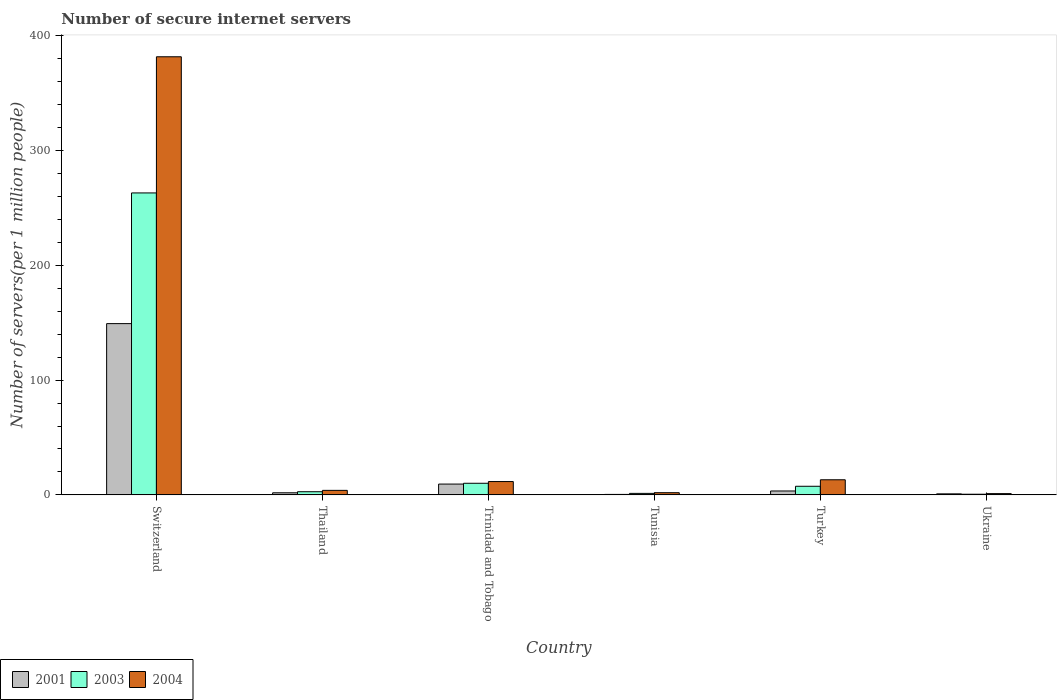How many different coloured bars are there?
Offer a terse response. 3. Are the number of bars on each tick of the X-axis equal?
Give a very brief answer. Yes. How many bars are there on the 1st tick from the left?
Offer a terse response. 3. How many bars are there on the 3rd tick from the right?
Ensure brevity in your answer.  3. What is the number of secure internet servers in 2001 in Turkey?
Keep it short and to the point. 3.41. Across all countries, what is the maximum number of secure internet servers in 2001?
Make the answer very short. 149.24. Across all countries, what is the minimum number of secure internet servers in 2004?
Make the answer very short. 1.12. In which country was the number of secure internet servers in 2003 maximum?
Provide a short and direct response. Switzerland. In which country was the number of secure internet servers in 2001 minimum?
Make the answer very short. Tunisia. What is the total number of secure internet servers in 2001 in the graph?
Provide a short and direct response. 165.23. What is the difference between the number of secure internet servers in 2003 in Trinidad and Tobago and that in Turkey?
Offer a very short reply. 2.62. What is the difference between the number of secure internet servers in 2003 in Trinidad and Tobago and the number of secure internet servers in 2001 in Turkey?
Ensure brevity in your answer.  6.71. What is the average number of secure internet servers in 2004 per country?
Offer a very short reply. 68.92. What is the difference between the number of secure internet servers of/in 2004 and number of secure internet servers of/in 2003 in Switzerland?
Provide a short and direct response. 118.64. In how many countries, is the number of secure internet servers in 2001 greater than 180?
Your answer should be compact. 0. What is the ratio of the number of secure internet servers in 2004 in Switzerland to that in Trinidad and Tobago?
Make the answer very short. 32.84. Is the number of secure internet servers in 2001 in Trinidad and Tobago less than that in Ukraine?
Offer a very short reply. No. What is the difference between the highest and the second highest number of secure internet servers in 2003?
Your answer should be compact. 2.62. What is the difference between the highest and the lowest number of secure internet servers in 2001?
Keep it short and to the point. 148.83. Is the sum of the number of secure internet servers in 2004 in Tunisia and Turkey greater than the maximum number of secure internet servers in 2003 across all countries?
Provide a short and direct response. No. What does the 1st bar from the left in Switzerland represents?
Ensure brevity in your answer.  2001. Is it the case that in every country, the sum of the number of secure internet servers in 2001 and number of secure internet servers in 2004 is greater than the number of secure internet servers in 2003?
Keep it short and to the point. Yes. How many bars are there?
Your answer should be compact. 18. Are all the bars in the graph horizontal?
Ensure brevity in your answer.  No. How many countries are there in the graph?
Provide a short and direct response. 6. What is the difference between two consecutive major ticks on the Y-axis?
Provide a succinct answer. 100. Are the values on the major ticks of Y-axis written in scientific E-notation?
Your answer should be very brief. No. How many legend labels are there?
Provide a short and direct response. 3. What is the title of the graph?
Make the answer very short. Number of secure internet servers. What is the label or title of the Y-axis?
Provide a short and direct response. Number of servers(per 1 million people). What is the Number of servers(per 1 million people) of 2001 in Switzerland?
Make the answer very short. 149.24. What is the Number of servers(per 1 million people) in 2003 in Switzerland?
Provide a short and direct response. 263.11. What is the Number of servers(per 1 million people) in 2004 in Switzerland?
Your answer should be compact. 381.75. What is the Number of servers(per 1 million people) of 2001 in Thailand?
Provide a short and direct response. 1.83. What is the Number of servers(per 1 million people) in 2003 in Thailand?
Provide a short and direct response. 2.76. What is the Number of servers(per 1 million people) of 2004 in Thailand?
Give a very brief answer. 3.94. What is the Number of servers(per 1 million people) in 2001 in Trinidad and Tobago?
Provide a succinct answer. 9.43. What is the Number of servers(per 1 million people) in 2003 in Trinidad and Tobago?
Provide a succinct answer. 10.12. What is the Number of servers(per 1 million people) of 2004 in Trinidad and Tobago?
Make the answer very short. 11.62. What is the Number of servers(per 1 million people) in 2001 in Tunisia?
Your response must be concise. 0.41. What is the Number of servers(per 1 million people) of 2003 in Tunisia?
Your answer should be very brief. 1.32. What is the Number of servers(per 1 million people) of 2004 in Tunisia?
Your answer should be compact. 1.91. What is the Number of servers(per 1 million people) in 2001 in Turkey?
Your answer should be very brief. 3.41. What is the Number of servers(per 1 million people) in 2003 in Turkey?
Give a very brief answer. 7.51. What is the Number of servers(per 1 million people) of 2004 in Turkey?
Give a very brief answer. 13.17. What is the Number of servers(per 1 million people) of 2001 in Ukraine?
Give a very brief answer. 0.9. What is the Number of servers(per 1 million people) in 2003 in Ukraine?
Your response must be concise. 0.59. What is the Number of servers(per 1 million people) in 2004 in Ukraine?
Your answer should be very brief. 1.12. Across all countries, what is the maximum Number of servers(per 1 million people) of 2001?
Provide a short and direct response. 149.24. Across all countries, what is the maximum Number of servers(per 1 million people) of 2003?
Offer a terse response. 263.11. Across all countries, what is the maximum Number of servers(per 1 million people) of 2004?
Keep it short and to the point. 381.75. Across all countries, what is the minimum Number of servers(per 1 million people) of 2001?
Your answer should be compact. 0.41. Across all countries, what is the minimum Number of servers(per 1 million people) of 2003?
Make the answer very short. 0.59. Across all countries, what is the minimum Number of servers(per 1 million people) of 2004?
Give a very brief answer. 1.12. What is the total Number of servers(per 1 million people) of 2001 in the graph?
Your response must be concise. 165.23. What is the total Number of servers(per 1 million people) of 2003 in the graph?
Offer a terse response. 285.42. What is the total Number of servers(per 1 million people) in 2004 in the graph?
Offer a terse response. 413.52. What is the difference between the Number of servers(per 1 million people) of 2001 in Switzerland and that in Thailand?
Make the answer very short. 147.41. What is the difference between the Number of servers(per 1 million people) of 2003 in Switzerland and that in Thailand?
Offer a terse response. 260.35. What is the difference between the Number of servers(per 1 million people) in 2004 in Switzerland and that in Thailand?
Your answer should be very brief. 377.81. What is the difference between the Number of servers(per 1 million people) of 2001 in Switzerland and that in Trinidad and Tobago?
Offer a very short reply. 139.81. What is the difference between the Number of servers(per 1 million people) in 2003 in Switzerland and that in Trinidad and Tobago?
Ensure brevity in your answer.  252.99. What is the difference between the Number of servers(per 1 million people) of 2004 in Switzerland and that in Trinidad and Tobago?
Your response must be concise. 370.13. What is the difference between the Number of servers(per 1 million people) in 2001 in Switzerland and that in Tunisia?
Keep it short and to the point. 148.83. What is the difference between the Number of servers(per 1 million people) in 2003 in Switzerland and that in Tunisia?
Make the answer very short. 261.79. What is the difference between the Number of servers(per 1 million people) of 2004 in Switzerland and that in Tunisia?
Offer a terse response. 379.84. What is the difference between the Number of servers(per 1 million people) of 2001 in Switzerland and that in Turkey?
Your answer should be very brief. 145.83. What is the difference between the Number of servers(per 1 million people) in 2003 in Switzerland and that in Turkey?
Keep it short and to the point. 255.61. What is the difference between the Number of servers(per 1 million people) of 2004 in Switzerland and that in Turkey?
Ensure brevity in your answer.  368.58. What is the difference between the Number of servers(per 1 million people) of 2001 in Switzerland and that in Ukraine?
Offer a terse response. 148.34. What is the difference between the Number of servers(per 1 million people) in 2003 in Switzerland and that in Ukraine?
Your response must be concise. 262.53. What is the difference between the Number of servers(per 1 million people) in 2004 in Switzerland and that in Ukraine?
Make the answer very short. 380.63. What is the difference between the Number of servers(per 1 million people) in 2001 in Thailand and that in Trinidad and Tobago?
Make the answer very short. -7.6. What is the difference between the Number of servers(per 1 million people) in 2003 in Thailand and that in Trinidad and Tobago?
Your answer should be very brief. -7.36. What is the difference between the Number of servers(per 1 million people) of 2004 in Thailand and that in Trinidad and Tobago?
Your answer should be compact. -7.68. What is the difference between the Number of servers(per 1 million people) in 2001 in Thailand and that in Tunisia?
Your answer should be very brief. 1.41. What is the difference between the Number of servers(per 1 million people) in 2003 in Thailand and that in Tunisia?
Provide a succinct answer. 1.44. What is the difference between the Number of servers(per 1 million people) in 2004 in Thailand and that in Tunisia?
Offer a terse response. 2.03. What is the difference between the Number of servers(per 1 million people) of 2001 in Thailand and that in Turkey?
Provide a short and direct response. -1.58. What is the difference between the Number of servers(per 1 million people) of 2003 in Thailand and that in Turkey?
Provide a short and direct response. -4.75. What is the difference between the Number of servers(per 1 million people) in 2004 in Thailand and that in Turkey?
Give a very brief answer. -9.22. What is the difference between the Number of servers(per 1 million people) in 2001 in Thailand and that in Ukraine?
Provide a succinct answer. 0.93. What is the difference between the Number of servers(per 1 million people) in 2003 in Thailand and that in Ukraine?
Provide a succinct answer. 2.18. What is the difference between the Number of servers(per 1 million people) of 2004 in Thailand and that in Ukraine?
Your answer should be compact. 2.83. What is the difference between the Number of servers(per 1 million people) of 2001 in Trinidad and Tobago and that in Tunisia?
Your response must be concise. 9.02. What is the difference between the Number of servers(per 1 million people) of 2003 in Trinidad and Tobago and that in Tunisia?
Your answer should be compact. 8.8. What is the difference between the Number of servers(per 1 million people) of 2004 in Trinidad and Tobago and that in Tunisia?
Your response must be concise. 9.71. What is the difference between the Number of servers(per 1 million people) in 2001 in Trinidad and Tobago and that in Turkey?
Offer a very short reply. 6.02. What is the difference between the Number of servers(per 1 million people) of 2003 in Trinidad and Tobago and that in Turkey?
Make the answer very short. 2.62. What is the difference between the Number of servers(per 1 million people) of 2004 in Trinidad and Tobago and that in Turkey?
Your response must be concise. -1.55. What is the difference between the Number of servers(per 1 million people) of 2001 in Trinidad and Tobago and that in Ukraine?
Offer a terse response. 8.53. What is the difference between the Number of servers(per 1 million people) of 2003 in Trinidad and Tobago and that in Ukraine?
Provide a succinct answer. 9.54. What is the difference between the Number of servers(per 1 million people) of 2004 in Trinidad and Tobago and that in Ukraine?
Offer a terse response. 10.51. What is the difference between the Number of servers(per 1 million people) of 2001 in Tunisia and that in Turkey?
Your answer should be very brief. -3. What is the difference between the Number of servers(per 1 million people) of 2003 in Tunisia and that in Turkey?
Your answer should be compact. -6.19. What is the difference between the Number of servers(per 1 million people) in 2004 in Tunisia and that in Turkey?
Offer a terse response. -11.26. What is the difference between the Number of servers(per 1 million people) in 2001 in Tunisia and that in Ukraine?
Keep it short and to the point. -0.49. What is the difference between the Number of servers(per 1 million people) of 2003 in Tunisia and that in Ukraine?
Offer a very short reply. 0.74. What is the difference between the Number of servers(per 1 million people) of 2004 in Tunisia and that in Ukraine?
Ensure brevity in your answer.  0.8. What is the difference between the Number of servers(per 1 million people) of 2001 in Turkey and that in Ukraine?
Your answer should be compact. 2.51. What is the difference between the Number of servers(per 1 million people) of 2003 in Turkey and that in Ukraine?
Give a very brief answer. 6.92. What is the difference between the Number of servers(per 1 million people) in 2004 in Turkey and that in Ukraine?
Offer a terse response. 12.05. What is the difference between the Number of servers(per 1 million people) of 2001 in Switzerland and the Number of servers(per 1 million people) of 2003 in Thailand?
Provide a short and direct response. 146.48. What is the difference between the Number of servers(per 1 million people) in 2001 in Switzerland and the Number of servers(per 1 million people) in 2004 in Thailand?
Make the answer very short. 145.3. What is the difference between the Number of servers(per 1 million people) of 2003 in Switzerland and the Number of servers(per 1 million people) of 2004 in Thailand?
Keep it short and to the point. 259.17. What is the difference between the Number of servers(per 1 million people) in 2001 in Switzerland and the Number of servers(per 1 million people) in 2003 in Trinidad and Tobago?
Provide a succinct answer. 139.12. What is the difference between the Number of servers(per 1 million people) in 2001 in Switzerland and the Number of servers(per 1 million people) in 2004 in Trinidad and Tobago?
Provide a short and direct response. 137.62. What is the difference between the Number of servers(per 1 million people) in 2003 in Switzerland and the Number of servers(per 1 million people) in 2004 in Trinidad and Tobago?
Offer a terse response. 251.49. What is the difference between the Number of servers(per 1 million people) of 2001 in Switzerland and the Number of servers(per 1 million people) of 2003 in Tunisia?
Your response must be concise. 147.92. What is the difference between the Number of servers(per 1 million people) in 2001 in Switzerland and the Number of servers(per 1 million people) in 2004 in Tunisia?
Keep it short and to the point. 147.33. What is the difference between the Number of servers(per 1 million people) in 2003 in Switzerland and the Number of servers(per 1 million people) in 2004 in Tunisia?
Give a very brief answer. 261.2. What is the difference between the Number of servers(per 1 million people) in 2001 in Switzerland and the Number of servers(per 1 million people) in 2003 in Turkey?
Make the answer very short. 141.73. What is the difference between the Number of servers(per 1 million people) in 2001 in Switzerland and the Number of servers(per 1 million people) in 2004 in Turkey?
Provide a succinct answer. 136.07. What is the difference between the Number of servers(per 1 million people) in 2003 in Switzerland and the Number of servers(per 1 million people) in 2004 in Turkey?
Your response must be concise. 249.95. What is the difference between the Number of servers(per 1 million people) of 2001 in Switzerland and the Number of servers(per 1 million people) of 2003 in Ukraine?
Give a very brief answer. 148.66. What is the difference between the Number of servers(per 1 million people) of 2001 in Switzerland and the Number of servers(per 1 million people) of 2004 in Ukraine?
Offer a terse response. 148.13. What is the difference between the Number of servers(per 1 million people) in 2003 in Switzerland and the Number of servers(per 1 million people) in 2004 in Ukraine?
Your answer should be very brief. 262. What is the difference between the Number of servers(per 1 million people) of 2001 in Thailand and the Number of servers(per 1 million people) of 2003 in Trinidad and Tobago?
Your answer should be compact. -8.29. What is the difference between the Number of servers(per 1 million people) in 2001 in Thailand and the Number of servers(per 1 million people) in 2004 in Trinidad and Tobago?
Your response must be concise. -9.79. What is the difference between the Number of servers(per 1 million people) of 2003 in Thailand and the Number of servers(per 1 million people) of 2004 in Trinidad and Tobago?
Your response must be concise. -8.86. What is the difference between the Number of servers(per 1 million people) of 2001 in Thailand and the Number of servers(per 1 million people) of 2003 in Tunisia?
Keep it short and to the point. 0.51. What is the difference between the Number of servers(per 1 million people) in 2001 in Thailand and the Number of servers(per 1 million people) in 2004 in Tunisia?
Your answer should be compact. -0.08. What is the difference between the Number of servers(per 1 million people) of 2003 in Thailand and the Number of servers(per 1 million people) of 2004 in Tunisia?
Offer a terse response. 0.85. What is the difference between the Number of servers(per 1 million people) of 2001 in Thailand and the Number of servers(per 1 million people) of 2003 in Turkey?
Offer a terse response. -5.68. What is the difference between the Number of servers(per 1 million people) in 2001 in Thailand and the Number of servers(per 1 million people) in 2004 in Turkey?
Provide a short and direct response. -11.34. What is the difference between the Number of servers(per 1 million people) of 2003 in Thailand and the Number of servers(per 1 million people) of 2004 in Turkey?
Your answer should be compact. -10.41. What is the difference between the Number of servers(per 1 million people) of 2001 in Thailand and the Number of servers(per 1 million people) of 2003 in Ukraine?
Your answer should be very brief. 1.24. What is the difference between the Number of servers(per 1 million people) of 2001 in Thailand and the Number of servers(per 1 million people) of 2004 in Ukraine?
Keep it short and to the point. 0.71. What is the difference between the Number of servers(per 1 million people) of 2003 in Thailand and the Number of servers(per 1 million people) of 2004 in Ukraine?
Offer a very short reply. 1.64. What is the difference between the Number of servers(per 1 million people) of 2001 in Trinidad and Tobago and the Number of servers(per 1 million people) of 2003 in Tunisia?
Offer a terse response. 8.11. What is the difference between the Number of servers(per 1 million people) of 2001 in Trinidad and Tobago and the Number of servers(per 1 million people) of 2004 in Tunisia?
Offer a very short reply. 7.52. What is the difference between the Number of servers(per 1 million people) in 2003 in Trinidad and Tobago and the Number of servers(per 1 million people) in 2004 in Tunisia?
Your answer should be compact. 8.21. What is the difference between the Number of servers(per 1 million people) in 2001 in Trinidad and Tobago and the Number of servers(per 1 million people) in 2003 in Turkey?
Provide a short and direct response. 1.92. What is the difference between the Number of servers(per 1 million people) in 2001 in Trinidad and Tobago and the Number of servers(per 1 million people) in 2004 in Turkey?
Give a very brief answer. -3.74. What is the difference between the Number of servers(per 1 million people) of 2003 in Trinidad and Tobago and the Number of servers(per 1 million people) of 2004 in Turkey?
Provide a succinct answer. -3.05. What is the difference between the Number of servers(per 1 million people) in 2001 in Trinidad and Tobago and the Number of servers(per 1 million people) in 2003 in Ukraine?
Your answer should be compact. 8.85. What is the difference between the Number of servers(per 1 million people) of 2001 in Trinidad and Tobago and the Number of servers(per 1 million people) of 2004 in Ukraine?
Make the answer very short. 8.31. What is the difference between the Number of servers(per 1 million people) of 2003 in Trinidad and Tobago and the Number of servers(per 1 million people) of 2004 in Ukraine?
Offer a very short reply. 9.01. What is the difference between the Number of servers(per 1 million people) in 2001 in Tunisia and the Number of servers(per 1 million people) in 2003 in Turkey?
Your response must be concise. -7.09. What is the difference between the Number of servers(per 1 million people) of 2001 in Tunisia and the Number of servers(per 1 million people) of 2004 in Turkey?
Give a very brief answer. -12.75. What is the difference between the Number of servers(per 1 million people) in 2003 in Tunisia and the Number of servers(per 1 million people) in 2004 in Turkey?
Your answer should be compact. -11.85. What is the difference between the Number of servers(per 1 million people) of 2001 in Tunisia and the Number of servers(per 1 million people) of 2003 in Ukraine?
Your response must be concise. -0.17. What is the difference between the Number of servers(per 1 million people) of 2001 in Tunisia and the Number of servers(per 1 million people) of 2004 in Ukraine?
Give a very brief answer. -0.7. What is the difference between the Number of servers(per 1 million people) of 2003 in Tunisia and the Number of servers(per 1 million people) of 2004 in Ukraine?
Give a very brief answer. 0.2. What is the difference between the Number of servers(per 1 million people) in 2001 in Turkey and the Number of servers(per 1 million people) in 2003 in Ukraine?
Your answer should be compact. 2.83. What is the difference between the Number of servers(per 1 million people) of 2001 in Turkey and the Number of servers(per 1 million people) of 2004 in Ukraine?
Provide a short and direct response. 2.3. What is the difference between the Number of servers(per 1 million people) of 2003 in Turkey and the Number of servers(per 1 million people) of 2004 in Ukraine?
Offer a terse response. 6.39. What is the average Number of servers(per 1 million people) of 2001 per country?
Offer a very short reply. 27.54. What is the average Number of servers(per 1 million people) in 2003 per country?
Ensure brevity in your answer.  47.57. What is the average Number of servers(per 1 million people) in 2004 per country?
Your answer should be very brief. 68.92. What is the difference between the Number of servers(per 1 million people) of 2001 and Number of servers(per 1 million people) of 2003 in Switzerland?
Keep it short and to the point. -113.87. What is the difference between the Number of servers(per 1 million people) of 2001 and Number of servers(per 1 million people) of 2004 in Switzerland?
Keep it short and to the point. -232.51. What is the difference between the Number of servers(per 1 million people) of 2003 and Number of servers(per 1 million people) of 2004 in Switzerland?
Ensure brevity in your answer.  -118.64. What is the difference between the Number of servers(per 1 million people) in 2001 and Number of servers(per 1 million people) in 2003 in Thailand?
Your answer should be compact. -0.93. What is the difference between the Number of servers(per 1 million people) of 2001 and Number of servers(per 1 million people) of 2004 in Thailand?
Offer a very short reply. -2.12. What is the difference between the Number of servers(per 1 million people) in 2003 and Number of servers(per 1 million people) in 2004 in Thailand?
Your response must be concise. -1.18. What is the difference between the Number of servers(per 1 million people) in 2001 and Number of servers(per 1 million people) in 2003 in Trinidad and Tobago?
Ensure brevity in your answer.  -0.69. What is the difference between the Number of servers(per 1 million people) in 2001 and Number of servers(per 1 million people) in 2004 in Trinidad and Tobago?
Offer a terse response. -2.19. What is the difference between the Number of servers(per 1 million people) in 2003 and Number of servers(per 1 million people) in 2004 in Trinidad and Tobago?
Give a very brief answer. -1.5. What is the difference between the Number of servers(per 1 million people) in 2001 and Number of servers(per 1 million people) in 2003 in Tunisia?
Provide a short and direct response. -0.91. What is the difference between the Number of servers(per 1 million people) in 2001 and Number of servers(per 1 million people) in 2004 in Tunisia?
Offer a very short reply. -1.5. What is the difference between the Number of servers(per 1 million people) in 2003 and Number of servers(per 1 million people) in 2004 in Tunisia?
Give a very brief answer. -0.59. What is the difference between the Number of servers(per 1 million people) of 2001 and Number of servers(per 1 million people) of 2003 in Turkey?
Your response must be concise. -4.1. What is the difference between the Number of servers(per 1 million people) in 2001 and Number of servers(per 1 million people) in 2004 in Turkey?
Your answer should be very brief. -9.76. What is the difference between the Number of servers(per 1 million people) of 2003 and Number of servers(per 1 million people) of 2004 in Turkey?
Make the answer very short. -5.66. What is the difference between the Number of servers(per 1 million people) in 2001 and Number of servers(per 1 million people) in 2003 in Ukraine?
Ensure brevity in your answer.  0.32. What is the difference between the Number of servers(per 1 million people) of 2001 and Number of servers(per 1 million people) of 2004 in Ukraine?
Your response must be concise. -0.21. What is the difference between the Number of servers(per 1 million people) of 2003 and Number of servers(per 1 million people) of 2004 in Ukraine?
Offer a terse response. -0.53. What is the ratio of the Number of servers(per 1 million people) in 2001 in Switzerland to that in Thailand?
Your answer should be compact. 81.59. What is the ratio of the Number of servers(per 1 million people) of 2003 in Switzerland to that in Thailand?
Your response must be concise. 95.28. What is the ratio of the Number of servers(per 1 million people) of 2004 in Switzerland to that in Thailand?
Offer a very short reply. 96.78. What is the ratio of the Number of servers(per 1 million people) in 2001 in Switzerland to that in Trinidad and Tobago?
Make the answer very short. 15.82. What is the ratio of the Number of servers(per 1 million people) of 2003 in Switzerland to that in Trinidad and Tobago?
Your response must be concise. 25.99. What is the ratio of the Number of servers(per 1 million people) of 2004 in Switzerland to that in Trinidad and Tobago?
Ensure brevity in your answer.  32.84. What is the ratio of the Number of servers(per 1 million people) in 2001 in Switzerland to that in Tunisia?
Provide a succinct answer. 360.07. What is the ratio of the Number of servers(per 1 million people) of 2003 in Switzerland to that in Tunisia?
Ensure brevity in your answer.  199.15. What is the ratio of the Number of servers(per 1 million people) in 2004 in Switzerland to that in Tunisia?
Ensure brevity in your answer.  199.56. What is the ratio of the Number of servers(per 1 million people) of 2001 in Switzerland to that in Turkey?
Provide a short and direct response. 43.74. What is the ratio of the Number of servers(per 1 million people) in 2003 in Switzerland to that in Turkey?
Give a very brief answer. 35.04. What is the ratio of the Number of servers(per 1 million people) of 2004 in Switzerland to that in Turkey?
Give a very brief answer. 28.99. What is the ratio of the Number of servers(per 1 million people) of 2001 in Switzerland to that in Ukraine?
Make the answer very short. 165.13. What is the ratio of the Number of servers(per 1 million people) of 2003 in Switzerland to that in Ukraine?
Your response must be concise. 449.3. What is the ratio of the Number of servers(per 1 million people) of 2004 in Switzerland to that in Ukraine?
Your answer should be compact. 341.79. What is the ratio of the Number of servers(per 1 million people) of 2001 in Thailand to that in Trinidad and Tobago?
Keep it short and to the point. 0.19. What is the ratio of the Number of servers(per 1 million people) in 2003 in Thailand to that in Trinidad and Tobago?
Your answer should be compact. 0.27. What is the ratio of the Number of servers(per 1 million people) of 2004 in Thailand to that in Trinidad and Tobago?
Provide a short and direct response. 0.34. What is the ratio of the Number of servers(per 1 million people) of 2001 in Thailand to that in Tunisia?
Ensure brevity in your answer.  4.41. What is the ratio of the Number of servers(per 1 million people) of 2003 in Thailand to that in Tunisia?
Your answer should be compact. 2.09. What is the ratio of the Number of servers(per 1 million people) in 2004 in Thailand to that in Tunisia?
Offer a terse response. 2.06. What is the ratio of the Number of servers(per 1 million people) of 2001 in Thailand to that in Turkey?
Provide a short and direct response. 0.54. What is the ratio of the Number of servers(per 1 million people) in 2003 in Thailand to that in Turkey?
Provide a succinct answer. 0.37. What is the ratio of the Number of servers(per 1 million people) in 2004 in Thailand to that in Turkey?
Your answer should be compact. 0.3. What is the ratio of the Number of servers(per 1 million people) of 2001 in Thailand to that in Ukraine?
Provide a short and direct response. 2.02. What is the ratio of the Number of servers(per 1 million people) in 2003 in Thailand to that in Ukraine?
Keep it short and to the point. 4.72. What is the ratio of the Number of servers(per 1 million people) of 2004 in Thailand to that in Ukraine?
Ensure brevity in your answer.  3.53. What is the ratio of the Number of servers(per 1 million people) in 2001 in Trinidad and Tobago to that in Tunisia?
Keep it short and to the point. 22.75. What is the ratio of the Number of servers(per 1 million people) of 2003 in Trinidad and Tobago to that in Tunisia?
Give a very brief answer. 7.66. What is the ratio of the Number of servers(per 1 million people) in 2004 in Trinidad and Tobago to that in Tunisia?
Keep it short and to the point. 6.08. What is the ratio of the Number of servers(per 1 million people) of 2001 in Trinidad and Tobago to that in Turkey?
Make the answer very short. 2.76. What is the ratio of the Number of servers(per 1 million people) of 2003 in Trinidad and Tobago to that in Turkey?
Offer a terse response. 1.35. What is the ratio of the Number of servers(per 1 million people) in 2004 in Trinidad and Tobago to that in Turkey?
Offer a terse response. 0.88. What is the ratio of the Number of servers(per 1 million people) in 2001 in Trinidad and Tobago to that in Ukraine?
Provide a succinct answer. 10.44. What is the ratio of the Number of servers(per 1 million people) in 2003 in Trinidad and Tobago to that in Ukraine?
Make the answer very short. 17.29. What is the ratio of the Number of servers(per 1 million people) of 2004 in Trinidad and Tobago to that in Ukraine?
Keep it short and to the point. 10.41. What is the ratio of the Number of servers(per 1 million people) in 2001 in Tunisia to that in Turkey?
Make the answer very short. 0.12. What is the ratio of the Number of servers(per 1 million people) of 2003 in Tunisia to that in Turkey?
Keep it short and to the point. 0.18. What is the ratio of the Number of servers(per 1 million people) of 2004 in Tunisia to that in Turkey?
Give a very brief answer. 0.15. What is the ratio of the Number of servers(per 1 million people) of 2001 in Tunisia to that in Ukraine?
Make the answer very short. 0.46. What is the ratio of the Number of servers(per 1 million people) in 2003 in Tunisia to that in Ukraine?
Give a very brief answer. 2.26. What is the ratio of the Number of servers(per 1 million people) in 2004 in Tunisia to that in Ukraine?
Keep it short and to the point. 1.71. What is the ratio of the Number of servers(per 1 million people) of 2001 in Turkey to that in Ukraine?
Keep it short and to the point. 3.78. What is the ratio of the Number of servers(per 1 million people) of 2003 in Turkey to that in Ukraine?
Provide a succinct answer. 12.82. What is the ratio of the Number of servers(per 1 million people) in 2004 in Turkey to that in Ukraine?
Offer a terse response. 11.79. What is the difference between the highest and the second highest Number of servers(per 1 million people) in 2001?
Give a very brief answer. 139.81. What is the difference between the highest and the second highest Number of servers(per 1 million people) in 2003?
Your response must be concise. 252.99. What is the difference between the highest and the second highest Number of servers(per 1 million people) of 2004?
Your answer should be compact. 368.58. What is the difference between the highest and the lowest Number of servers(per 1 million people) in 2001?
Your answer should be very brief. 148.83. What is the difference between the highest and the lowest Number of servers(per 1 million people) in 2003?
Provide a short and direct response. 262.53. What is the difference between the highest and the lowest Number of servers(per 1 million people) of 2004?
Offer a terse response. 380.63. 